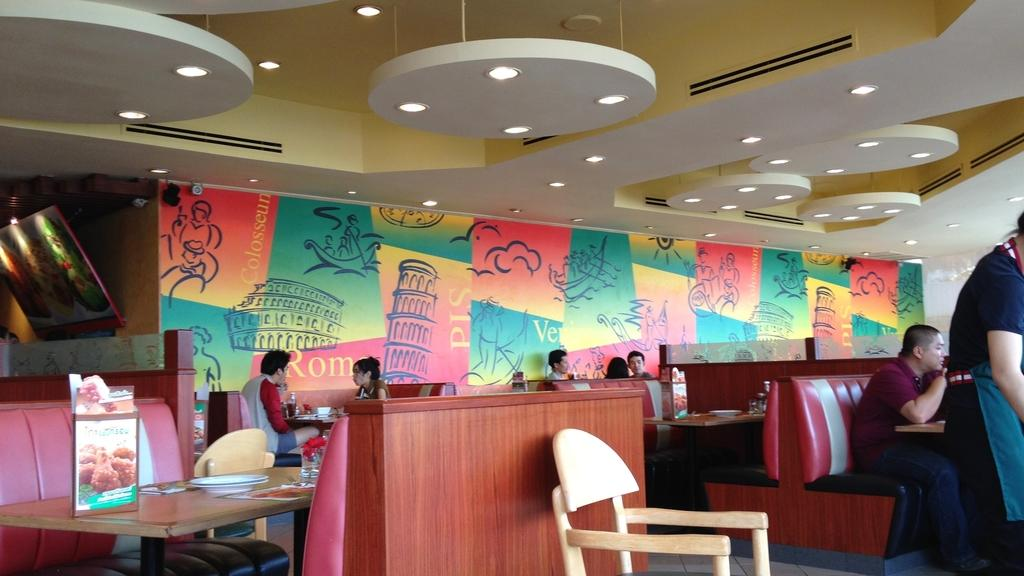How many people are in the image? There is a group of people in the image. Where are the people located in the image? The group of people is sitting in a restaurant. Can you describe the presence of a staff member in the image? Yes, there is a server in the right cornered on the right side of the image. What type of cub can be seen playing with a cover in the image? There is no cub or cover present in the image. Is there a carpenter working on a table in the image? There is no carpenter or table being worked on in the image. 